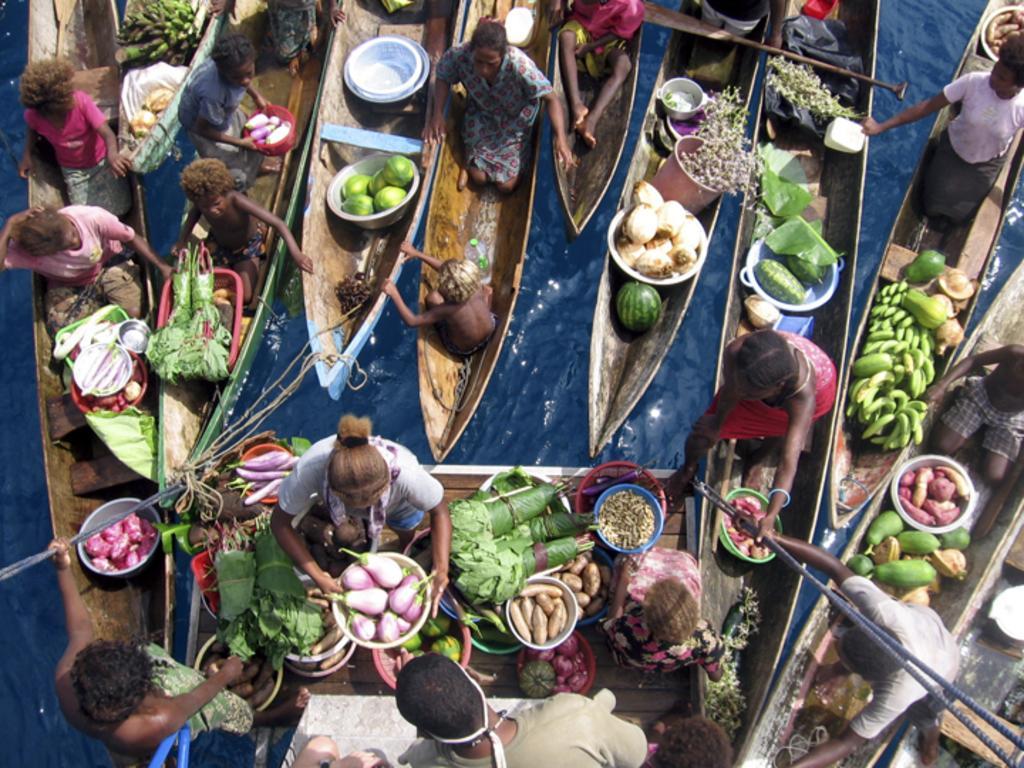In one or two sentences, can you explain what this image depicts? This image consists of so many boats. In that there are so many persons and vegetables. Vegetables such as brinjal, potato, leafy vegetables. There is water in this image. 